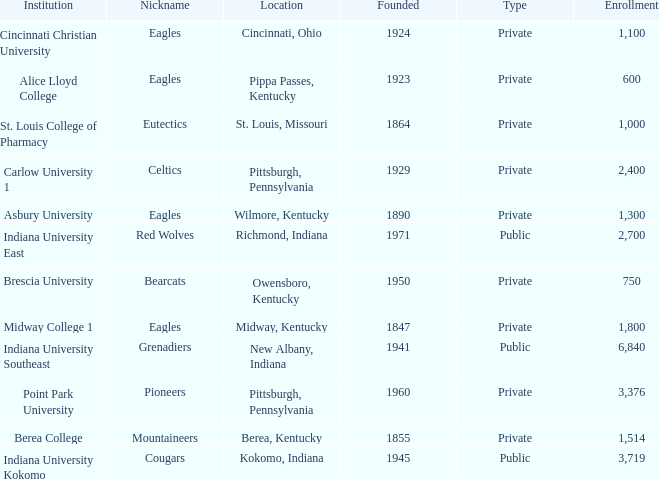Which of the private colleges is the oldest, and whose nickname is the Mountaineers? 1855.0. 